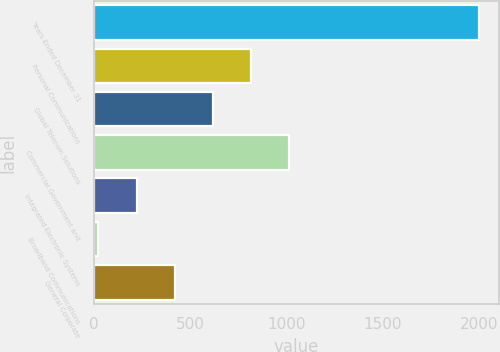Convert chart to OTSL. <chart><loc_0><loc_0><loc_500><loc_500><bar_chart><fcel>Years Ended December 31<fcel>Personal Communications<fcel>Global Telecom Solutions<fcel>Commercial Government and<fcel>Integrated Electronic Systems<fcel>Broadband Communications<fcel>General Corporate<nl><fcel>2003<fcel>815<fcel>617<fcel>1013<fcel>221<fcel>23<fcel>419<nl></chart> 